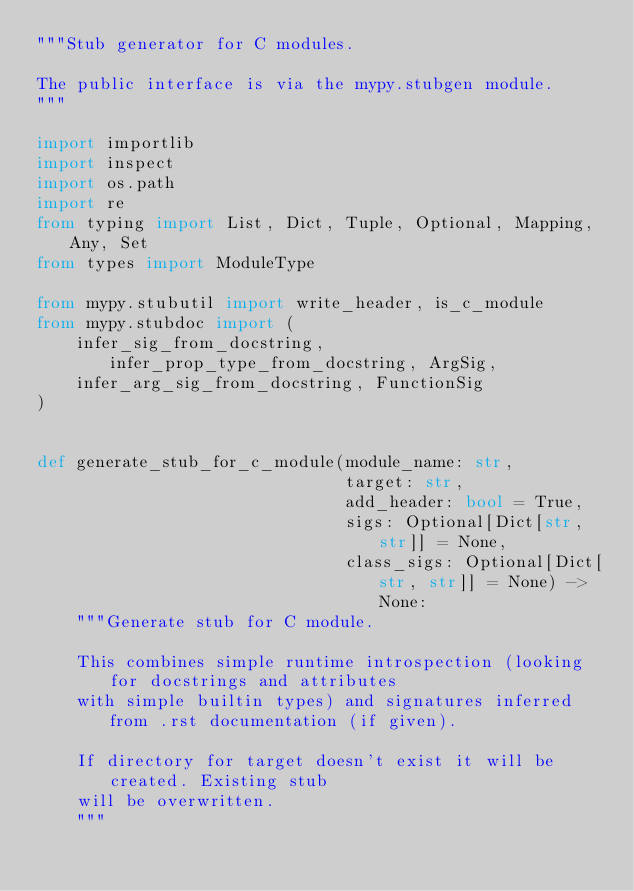<code> <loc_0><loc_0><loc_500><loc_500><_Python_>"""Stub generator for C modules.

The public interface is via the mypy.stubgen module.
"""

import importlib
import inspect
import os.path
import re
from typing import List, Dict, Tuple, Optional, Mapping, Any, Set
from types import ModuleType

from mypy.stubutil import write_header, is_c_module
from mypy.stubdoc import (
    infer_sig_from_docstring, infer_prop_type_from_docstring, ArgSig,
    infer_arg_sig_from_docstring, FunctionSig
)


def generate_stub_for_c_module(module_name: str,
                               target: str,
                               add_header: bool = True,
                               sigs: Optional[Dict[str, str]] = None,
                               class_sigs: Optional[Dict[str, str]] = None) -> None:
    """Generate stub for C module.

    This combines simple runtime introspection (looking for docstrings and attributes
    with simple builtin types) and signatures inferred from .rst documentation (if given).

    If directory for target doesn't exist it will be created. Existing stub
    will be overwritten.
    """</code> 